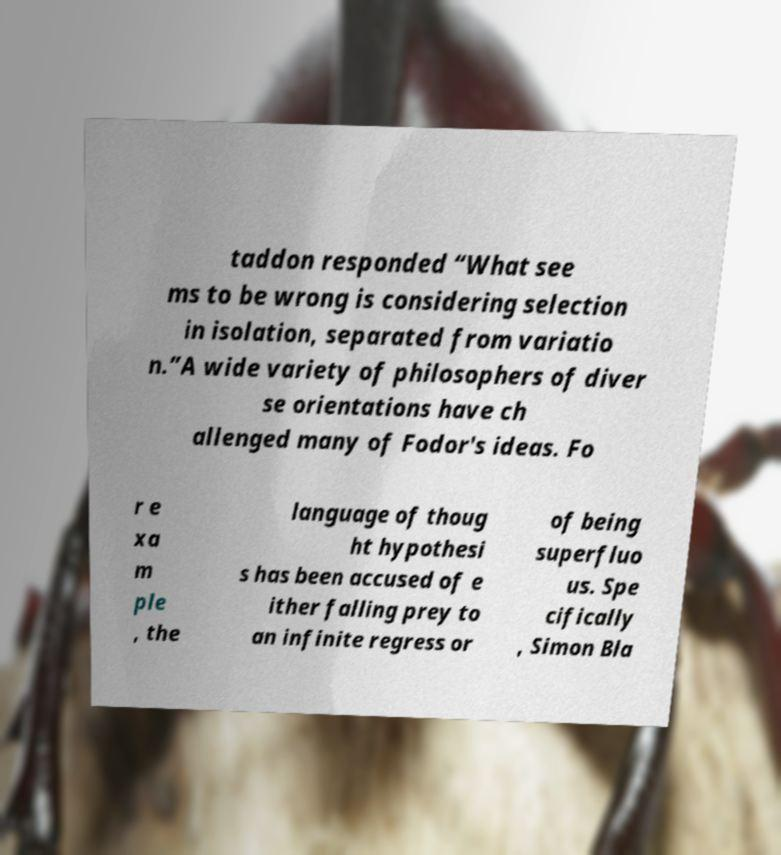Please read and relay the text visible in this image. What does it say? taddon responded “What see ms to be wrong is considering selection in isolation, separated from variatio n.”A wide variety of philosophers of diver se orientations have ch allenged many of Fodor's ideas. Fo r e xa m ple , the language of thoug ht hypothesi s has been accused of e ither falling prey to an infinite regress or of being superfluo us. Spe cifically , Simon Bla 